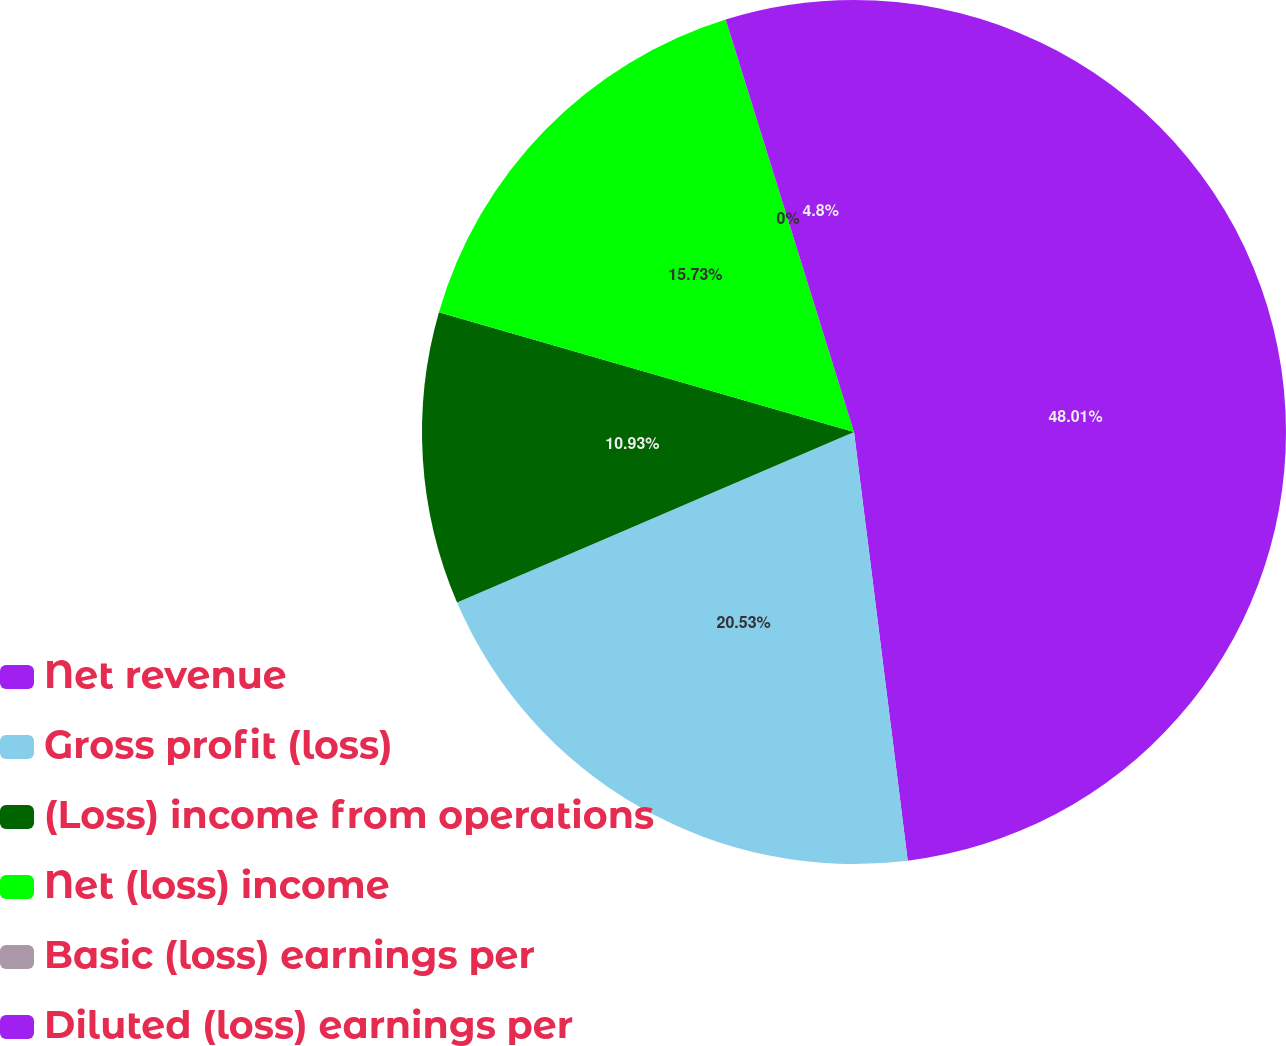<chart> <loc_0><loc_0><loc_500><loc_500><pie_chart><fcel>Net revenue<fcel>Gross profit (loss)<fcel>(Loss) income from operations<fcel>Net (loss) income<fcel>Basic (loss) earnings per<fcel>Diluted (loss) earnings per<nl><fcel>48.02%<fcel>20.53%<fcel>10.93%<fcel>15.73%<fcel>0.0%<fcel>4.8%<nl></chart> 